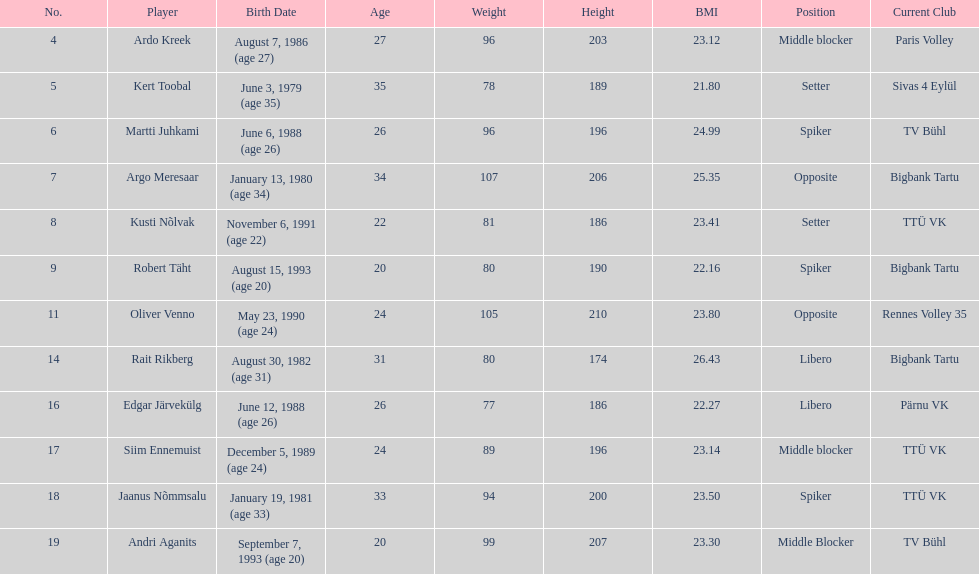Kert toobal is the oldest who is the next oldest player listed? Argo Meresaar. 